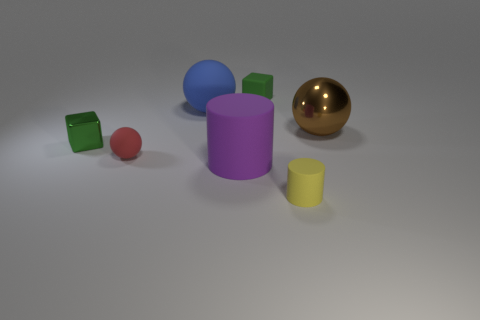Add 2 green objects. How many objects exist? 9 Subtract all balls. How many objects are left? 4 Subtract 0 gray blocks. How many objects are left? 7 Subtract all brown metallic balls. Subtract all green objects. How many objects are left? 4 Add 2 blocks. How many blocks are left? 4 Add 1 tiny red objects. How many tiny red objects exist? 2 